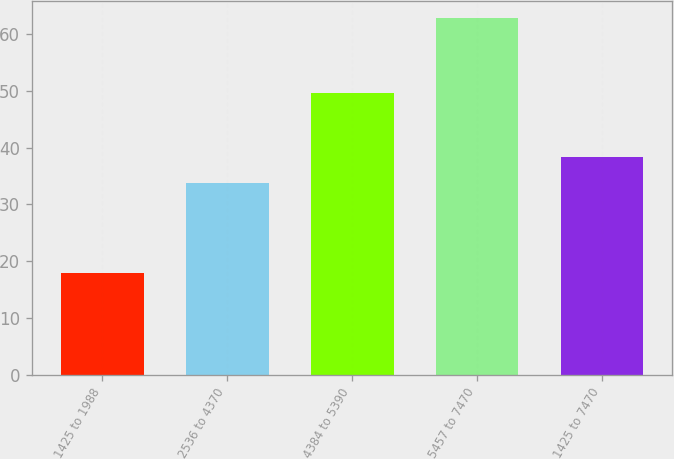<chart> <loc_0><loc_0><loc_500><loc_500><bar_chart><fcel>1425 to 1988<fcel>2536 to 4370<fcel>4384 to 5390<fcel>5457 to 7470<fcel>1425 to 7470<nl><fcel>17.98<fcel>33.82<fcel>49.52<fcel>62.75<fcel>38.3<nl></chart> 